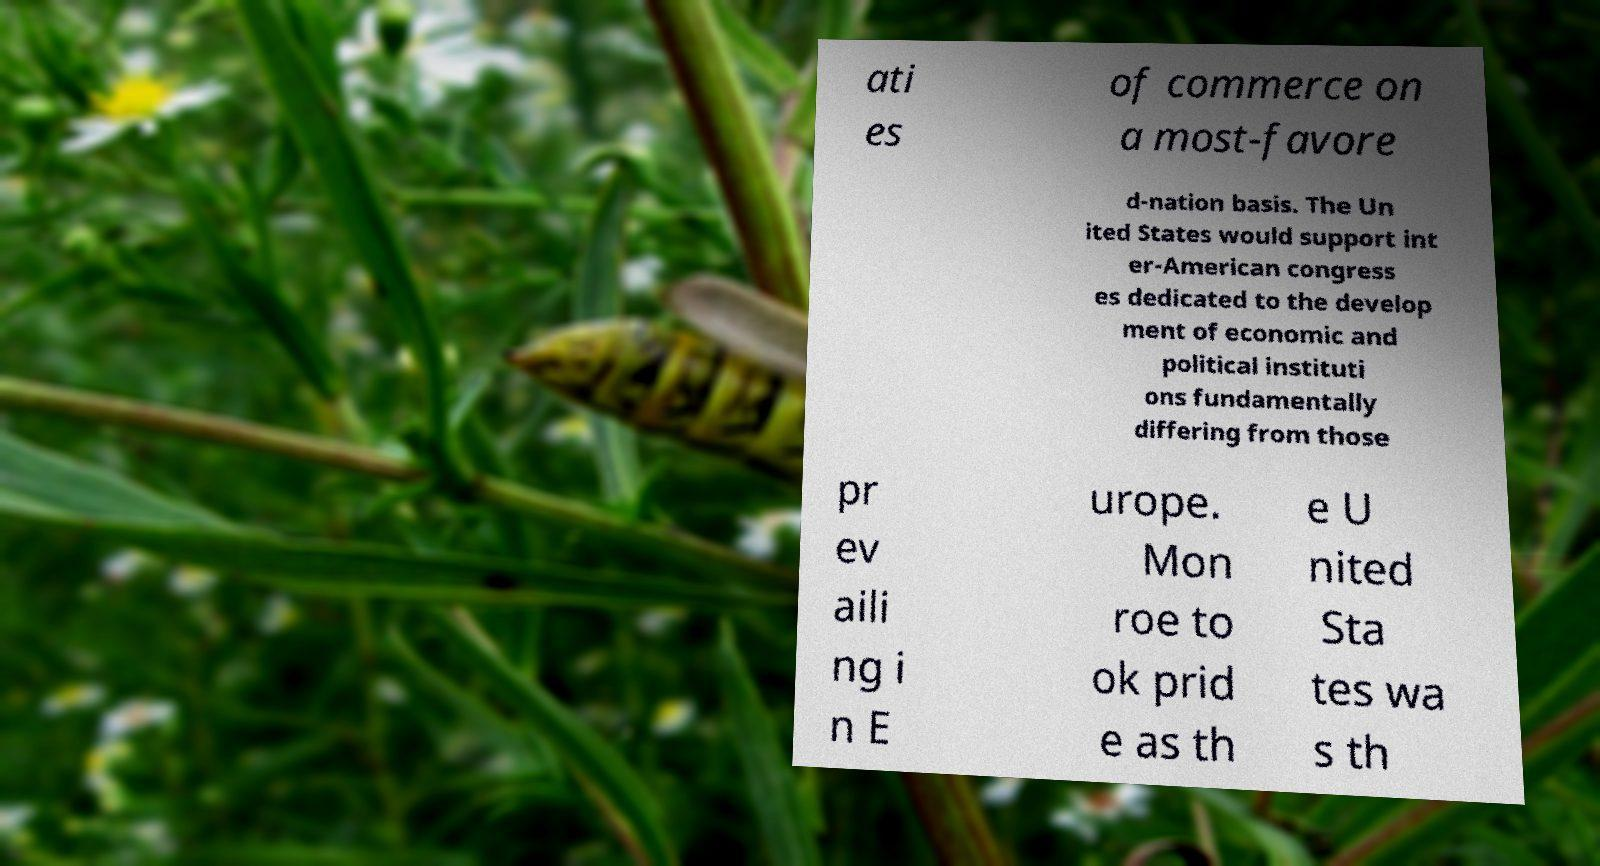Could you assist in decoding the text presented in this image and type it out clearly? ati es of commerce on a most-favore d-nation basis. The Un ited States would support int er-American congress es dedicated to the develop ment of economic and political instituti ons fundamentally differing from those pr ev aili ng i n E urope. Mon roe to ok prid e as th e U nited Sta tes wa s th 